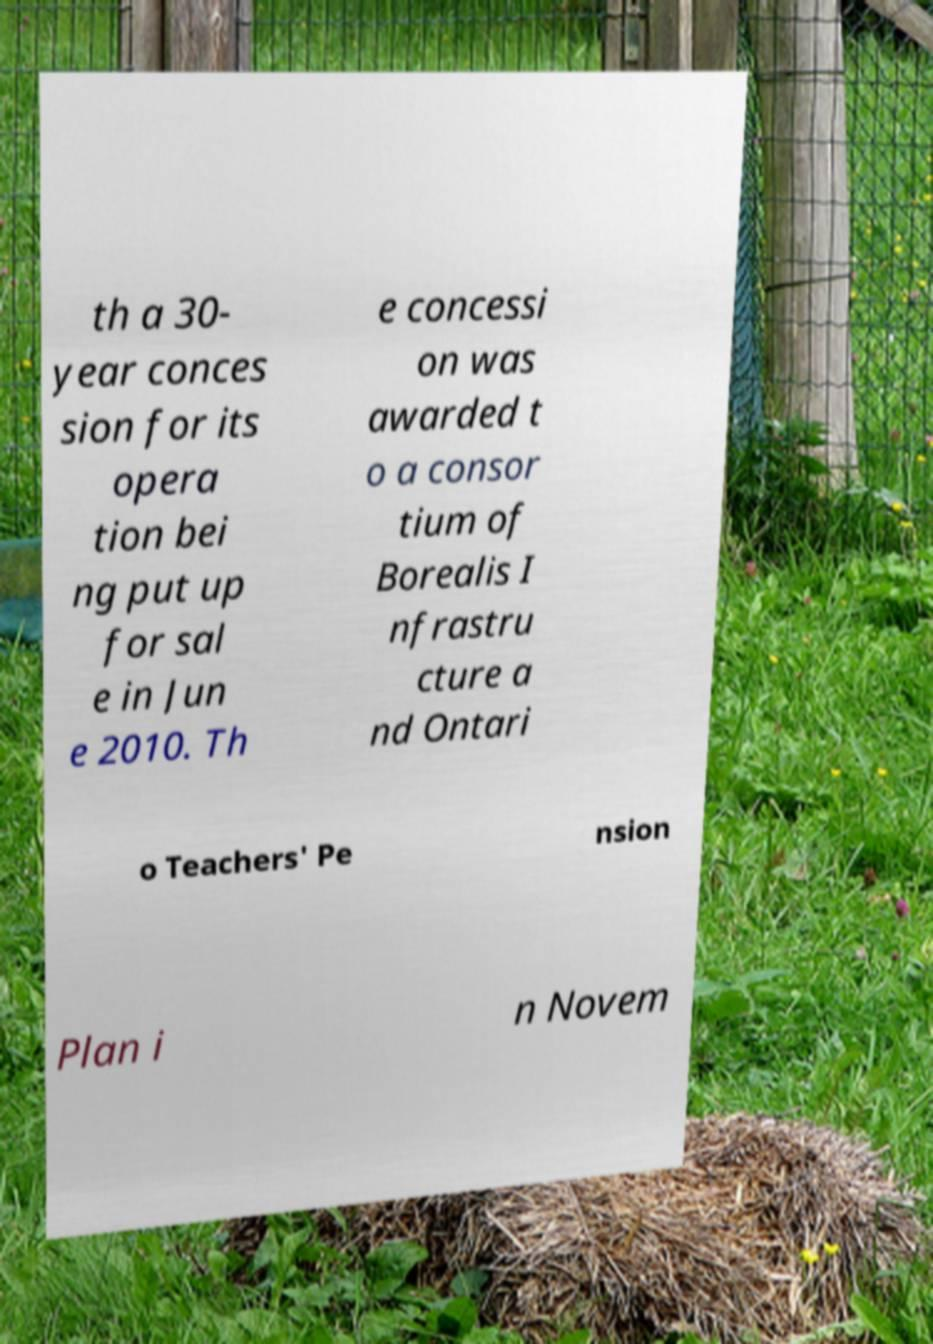Can you read and provide the text displayed in the image?This photo seems to have some interesting text. Can you extract and type it out for me? th a 30- year conces sion for its opera tion bei ng put up for sal e in Jun e 2010. Th e concessi on was awarded t o a consor tium of Borealis I nfrastru cture a nd Ontari o Teachers' Pe nsion Plan i n Novem 